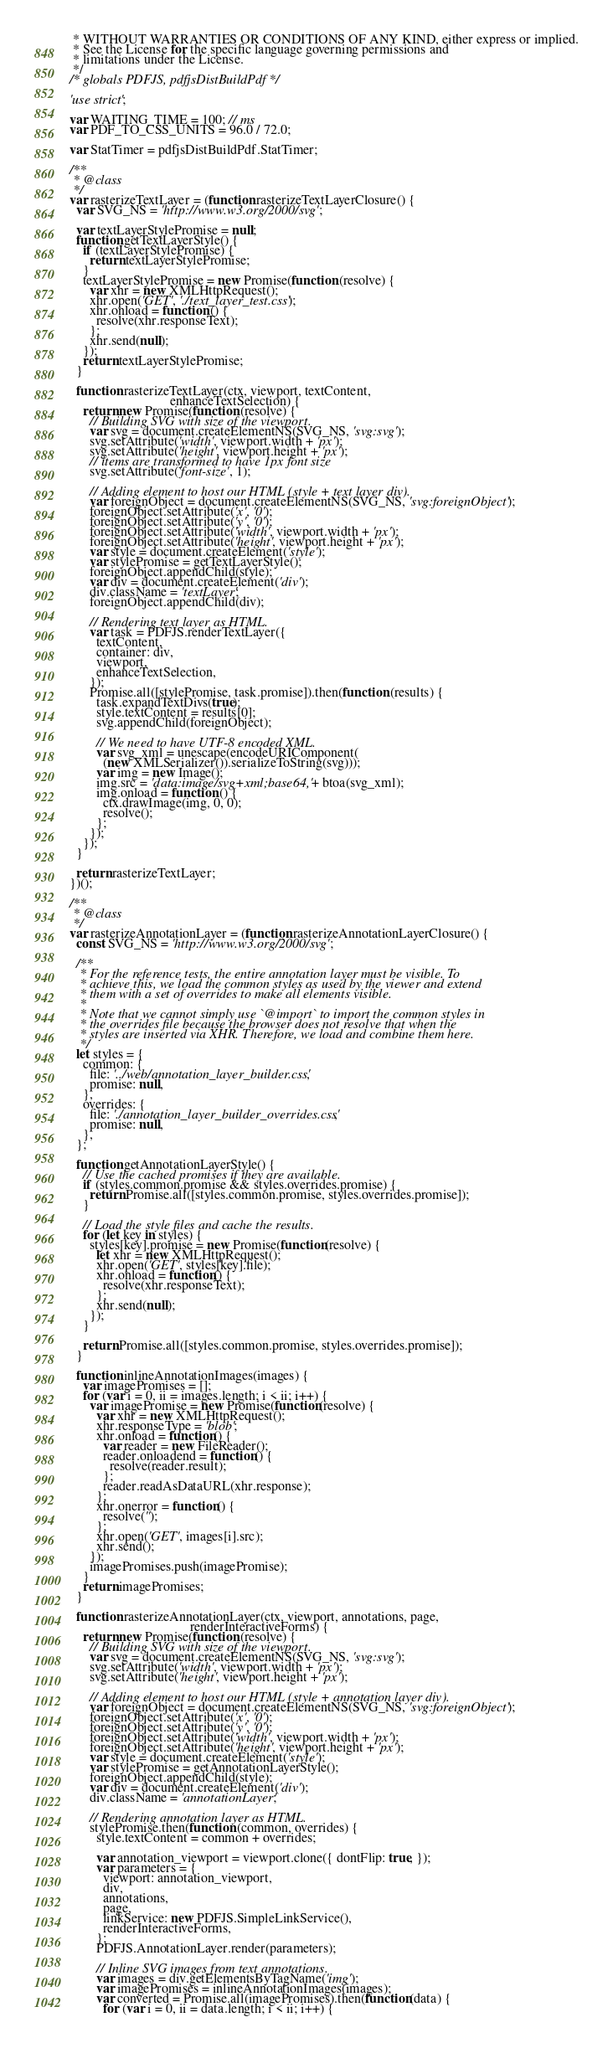Convert code to text. <code><loc_0><loc_0><loc_500><loc_500><_JavaScript_> * WITHOUT WARRANTIES OR CONDITIONS OF ANY KIND, either express or implied.
 * See the License for the specific language governing permissions and
 * limitations under the License.
 */
/* globals PDFJS, pdfjsDistBuildPdf */

'use strict';

var WAITING_TIME = 100; // ms
var PDF_TO_CSS_UNITS = 96.0 / 72.0;

var StatTimer = pdfjsDistBuildPdf.StatTimer;

/**
 * @class
 */
var rasterizeTextLayer = (function rasterizeTextLayerClosure() {
  var SVG_NS = 'http://www.w3.org/2000/svg';

  var textLayerStylePromise = null;
  function getTextLayerStyle() {
    if (textLayerStylePromise) {
      return textLayerStylePromise;
    }
    textLayerStylePromise = new Promise(function (resolve) {
      var xhr = new XMLHttpRequest();
      xhr.open('GET', './text_layer_test.css');
      xhr.onload = function () {
        resolve(xhr.responseText);
      };
      xhr.send(null);
    });
    return textLayerStylePromise;
  }

  function rasterizeTextLayer(ctx, viewport, textContent,
                              enhanceTextSelection) {
    return new Promise(function (resolve) {
      // Building SVG with size of the viewport.
      var svg = document.createElementNS(SVG_NS, 'svg:svg');
      svg.setAttribute('width', viewport.width + 'px');
      svg.setAttribute('height', viewport.height + 'px');
      // items are transformed to have 1px font size
      svg.setAttribute('font-size', 1);

      // Adding element to host our HTML (style + text layer div).
      var foreignObject = document.createElementNS(SVG_NS, 'svg:foreignObject');
      foreignObject.setAttribute('x', '0');
      foreignObject.setAttribute('y', '0');
      foreignObject.setAttribute('width', viewport.width + 'px');
      foreignObject.setAttribute('height', viewport.height + 'px');
      var style = document.createElement('style');
      var stylePromise = getTextLayerStyle();
      foreignObject.appendChild(style);
      var div = document.createElement('div');
      div.className = 'textLayer';
      foreignObject.appendChild(div);

      // Rendering text layer as HTML.
      var task = PDFJS.renderTextLayer({
        textContent,
        container: div,
        viewport,
        enhanceTextSelection,
      });
      Promise.all([stylePromise, task.promise]).then(function (results) {
        task.expandTextDivs(true);
        style.textContent = results[0];
        svg.appendChild(foreignObject);

        // We need to have UTF-8 encoded XML.
        var svg_xml = unescape(encodeURIComponent(
          (new XMLSerializer()).serializeToString(svg)));
        var img = new Image();
        img.src = 'data:image/svg+xml;base64,' + btoa(svg_xml);
        img.onload = function () {
          ctx.drawImage(img, 0, 0);
          resolve();
        };
      });
    });
  }

  return rasterizeTextLayer;
})();

/**
 * @class
 */
var rasterizeAnnotationLayer = (function rasterizeAnnotationLayerClosure() {
  const SVG_NS = 'http://www.w3.org/2000/svg';

  /**
   * For the reference tests, the entire annotation layer must be visible. To
   * achieve this, we load the common styles as used by the viewer and extend
   * them with a set of overrides to make all elements visible.
   *
   * Note that we cannot simply use `@import` to import the common styles in
   * the overrides file because the browser does not resolve that when the
   * styles are inserted via XHR. Therefore, we load and combine them here.
   */
  let styles = {
    common: {
      file: '../web/annotation_layer_builder.css',
      promise: null,
    },
    overrides: {
      file: './annotation_layer_builder_overrides.css',
      promise: null,
    },
  };

  function getAnnotationLayerStyle() {
    // Use the cached promises if they are available.
    if (styles.common.promise && styles.overrides.promise) {
      return Promise.all([styles.common.promise, styles.overrides.promise]);
    }

    // Load the style files and cache the results.
    for (let key in styles) {
      styles[key].promise = new Promise(function(resolve) {
        let xhr = new XMLHttpRequest();
        xhr.open('GET', styles[key].file);
        xhr.onload = function() {
          resolve(xhr.responseText);
        };
        xhr.send(null);
      });
    }

    return Promise.all([styles.common.promise, styles.overrides.promise]);
  }

  function inlineAnnotationImages(images) {
    var imagePromises = [];
    for (var i = 0, ii = images.length; i < ii; i++) {
      var imagePromise = new Promise(function(resolve) {
        var xhr = new XMLHttpRequest();
        xhr.responseType = 'blob';
        xhr.onload = function() {
          var reader = new FileReader();
          reader.onloadend = function() {
            resolve(reader.result);
          };
          reader.readAsDataURL(xhr.response);
        };
        xhr.onerror = function() {
          resolve('');
        };
        xhr.open('GET', images[i].src);
        xhr.send();
      });
      imagePromises.push(imagePromise);
    }
    return imagePromises;
  }

  function rasterizeAnnotationLayer(ctx, viewport, annotations, page,
                                    renderInteractiveForms) {
    return new Promise(function (resolve) {
      // Building SVG with size of the viewport.
      var svg = document.createElementNS(SVG_NS, 'svg:svg');
      svg.setAttribute('width', viewport.width + 'px');
      svg.setAttribute('height', viewport.height + 'px');

      // Adding element to host our HTML (style + annotation layer div).
      var foreignObject = document.createElementNS(SVG_NS, 'svg:foreignObject');
      foreignObject.setAttribute('x', '0');
      foreignObject.setAttribute('y', '0');
      foreignObject.setAttribute('width', viewport.width + 'px');
      foreignObject.setAttribute('height', viewport.height + 'px');
      var style = document.createElement('style');
      var stylePromise = getAnnotationLayerStyle();
      foreignObject.appendChild(style);
      var div = document.createElement('div');
      div.className = 'annotationLayer';

      // Rendering annotation layer as HTML.
      stylePromise.then(function (common, overrides) {
        style.textContent = common + overrides;

        var annotation_viewport = viewport.clone({ dontFlip: true, });
        var parameters = {
          viewport: annotation_viewport,
          div,
          annotations,
          page,
          linkService: new PDFJS.SimpleLinkService(),
          renderInteractiveForms,
        };
        PDFJS.AnnotationLayer.render(parameters);

        // Inline SVG images from text annotations.
        var images = div.getElementsByTagName('img');
        var imagePromises = inlineAnnotationImages(images);
        var converted = Promise.all(imagePromises).then(function(data) {
          for (var i = 0, ii = data.length; i < ii; i++) {</code> 